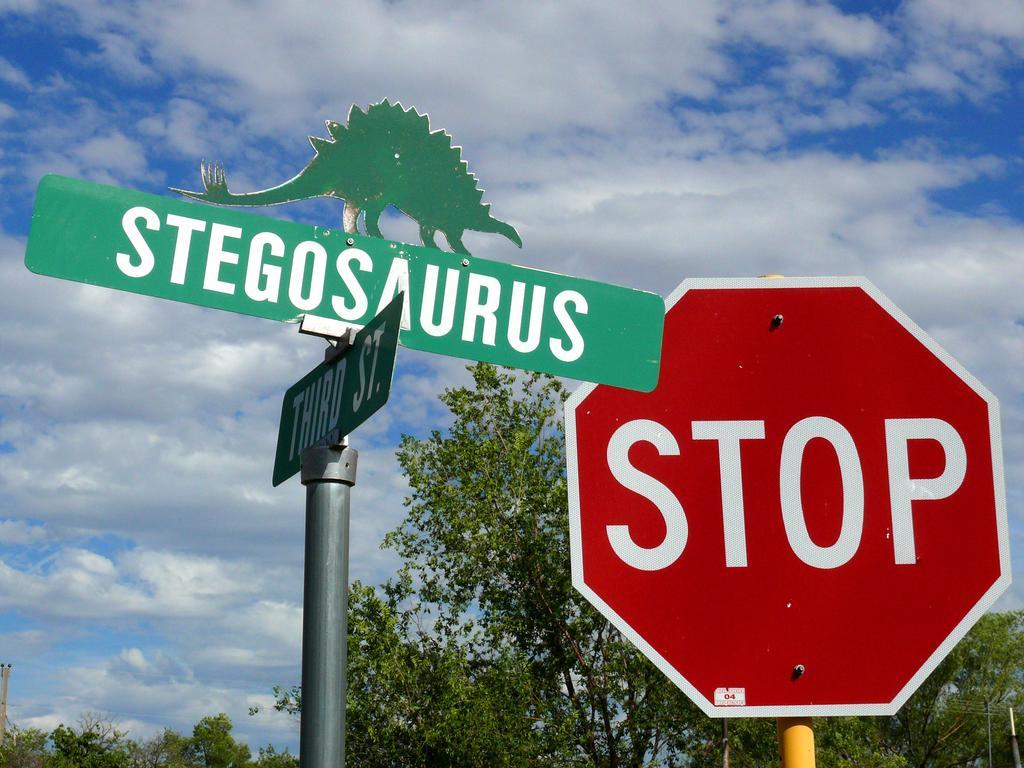In one or two sentences, can you explain what this image depicts? In this image there is a signboard and direction boards attached to the poles, and in the background there are trees, sky. 